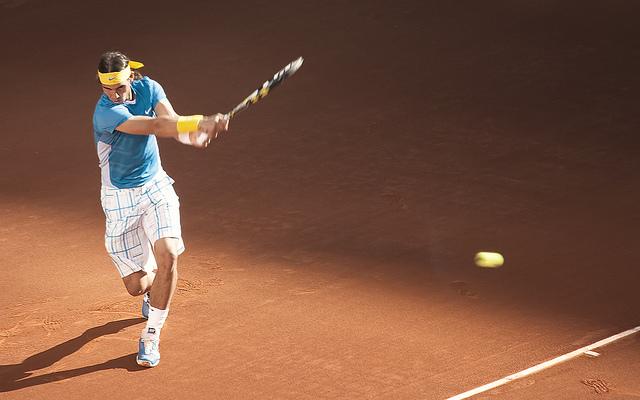What color is the ball?
Answer briefly. Yellow. Are the wristbands the same color as the ball?
Keep it brief. Yes. IS this person playing baseball?
Concise answer only. No. 